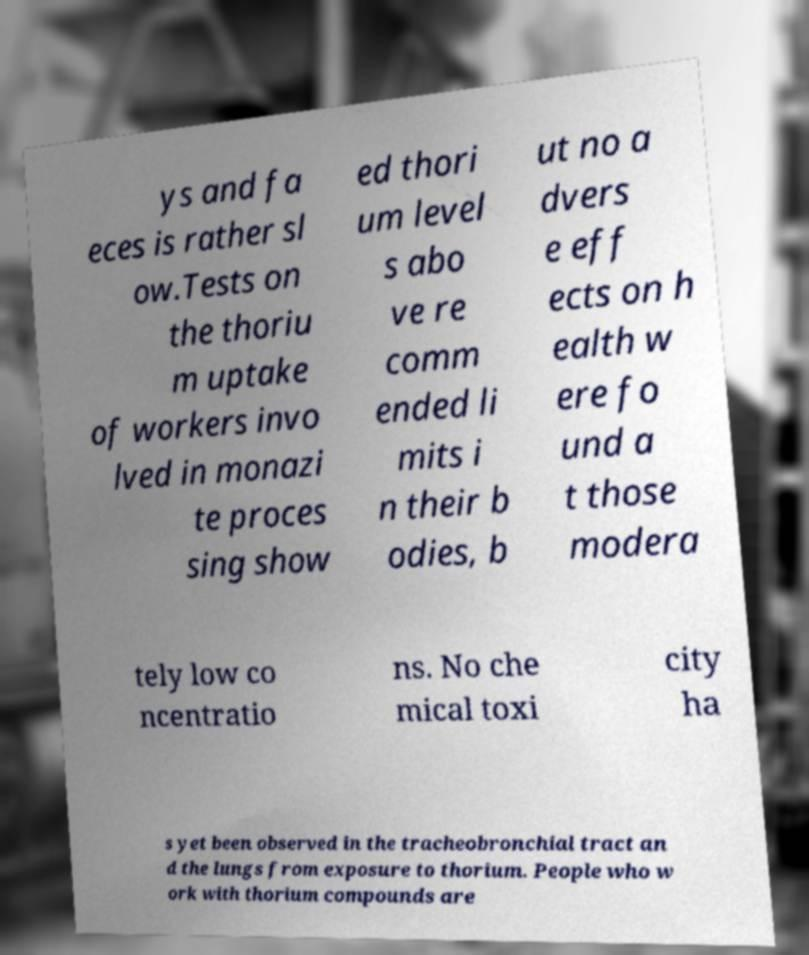Could you assist in decoding the text presented in this image and type it out clearly? ys and fa eces is rather sl ow.Tests on the thoriu m uptake of workers invo lved in monazi te proces sing show ed thori um level s abo ve re comm ended li mits i n their b odies, b ut no a dvers e eff ects on h ealth w ere fo und a t those modera tely low co ncentratio ns. No che mical toxi city ha s yet been observed in the tracheobronchial tract an d the lungs from exposure to thorium. People who w ork with thorium compounds are 